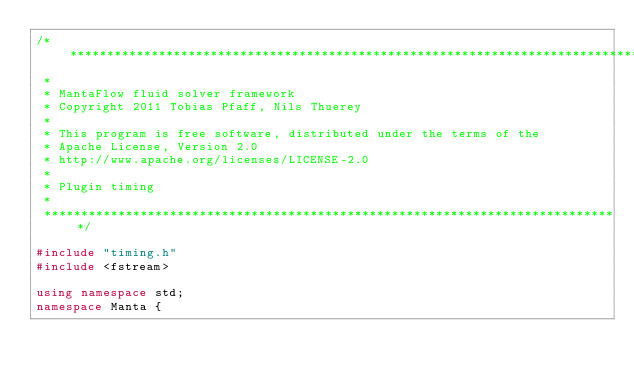Convert code to text. <code><loc_0><loc_0><loc_500><loc_500><_C++_>/******************************************************************************
 *
 * MantaFlow fluid solver framework
 * Copyright 2011 Tobias Pfaff, Nils Thuerey 
 *
 * This program is free software, distributed under the terms of the
 * Apache License, Version 2.0 
 * http://www.apache.org/licenses/LICENSE-2.0
 *
 * Plugin timing
 *
 ******************************************************************************/

#include "timing.h"
#include <fstream>

using namespace std;
namespace Manta {
</code> 